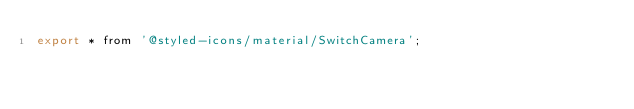Convert code to text. <code><loc_0><loc_0><loc_500><loc_500><_JavaScript_>export * from '@styled-icons/material/SwitchCamera';
</code> 